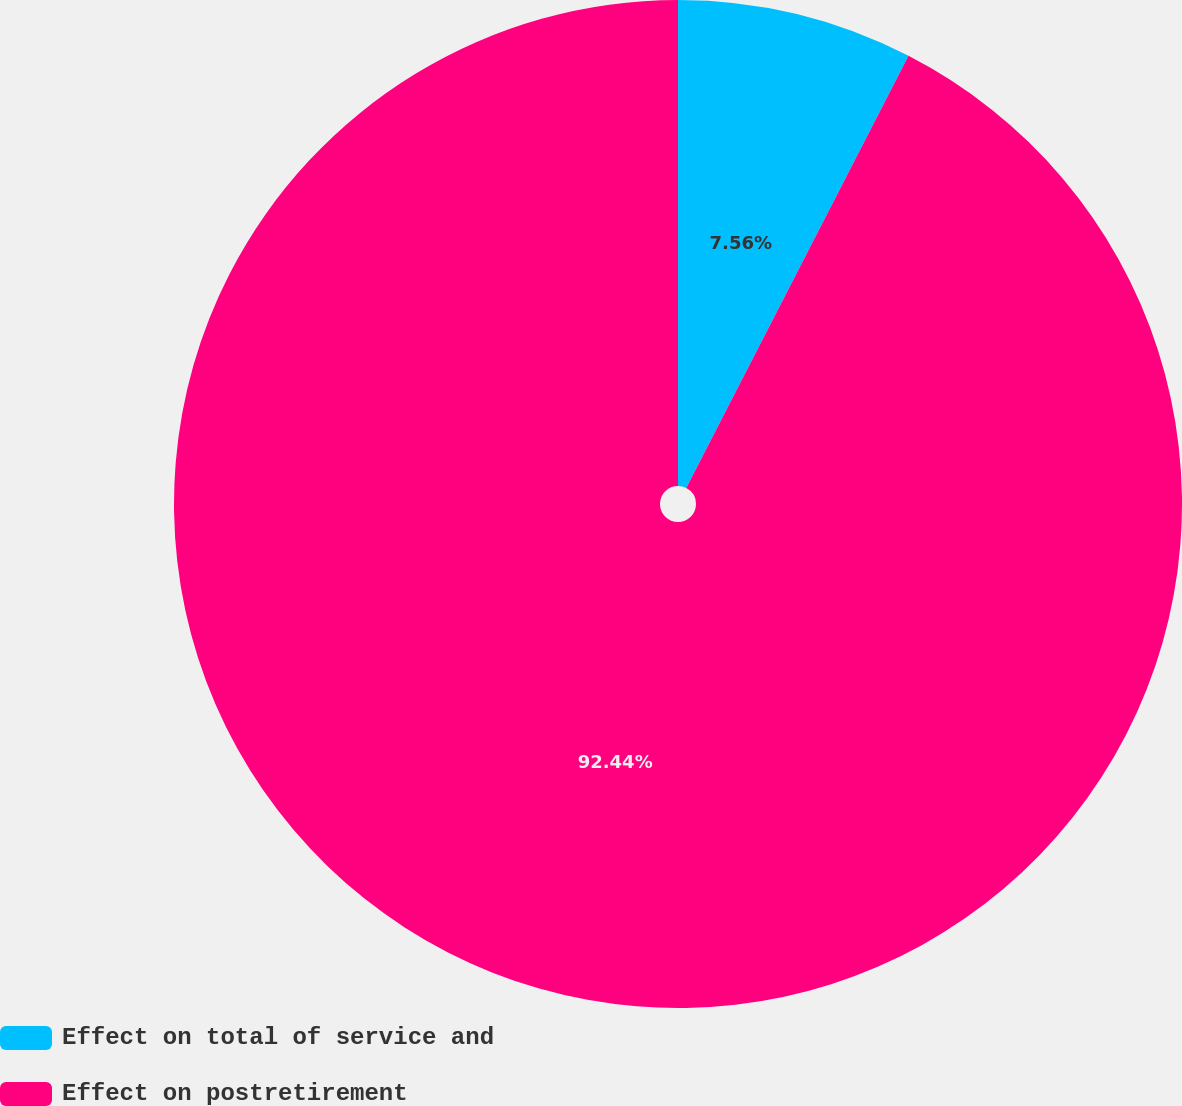Convert chart to OTSL. <chart><loc_0><loc_0><loc_500><loc_500><pie_chart><fcel>Effect on total of service and<fcel>Effect on postretirement<nl><fcel>7.56%<fcel>92.44%<nl></chart> 